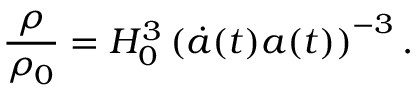Convert formula to latex. <formula><loc_0><loc_0><loc_500><loc_500>\frac { \rho } { \rho _ { 0 } } = H _ { 0 } ^ { 3 } \left ( \ D o t { a } ( t ) a ( t ) \right ) ^ { - 3 } .</formula> 